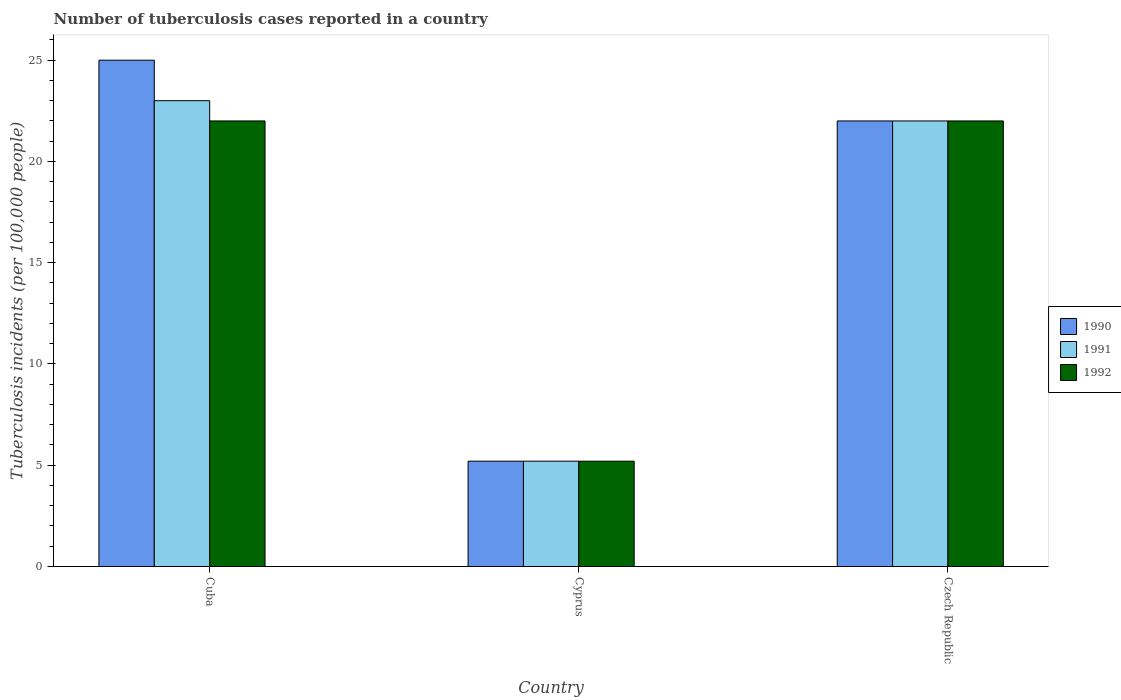How many groups of bars are there?
Ensure brevity in your answer.  3. Are the number of bars per tick equal to the number of legend labels?
Your response must be concise. Yes. Are the number of bars on each tick of the X-axis equal?
Provide a short and direct response. Yes. What is the label of the 1st group of bars from the left?
Your answer should be very brief. Cuba. Across all countries, what is the minimum number of tuberculosis cases reported in in 1991?
Your answer should be very brief. 5.2. In which country was the number of tuberculosis cases reported in in 1991 maximum?
Offer a very short reply. Cuba. In which country was the number of tuberculosis cases reported in in 1991 minimum?
Your answer should be very brief. Cyprus. What is the total number of tuberculosis cases reported in in 1991 in the graph?
Ensure brevity in your answer.  50.2. What is the difference between the number of tuberculosis cases reported in in 1992 in Cyprus and that in Czech Republic?
Make the answer very short. -16.8. What is the difference between the number of tuberculosis cases reported in in 1991 in Cyprus and the number of tuberculosis cases reported in in 1992 in Czech Republic?
Ensure brevity in your answer.  -16.8. What is the average number of tuberculosis cases reported in in 1992 per country?
Make the answer very short. 16.4. In how many countries, is the number of tuberculosis cases reported in in 1990 greater than 12?
Ensure brevity in your answer.  2. What is the ratio of the number of tuberculosis cases reported in in 1992 in Cuba to that in Czech Republic?
Your answer should be very brief. 1. Is the difference between the number of tuberculosis cases reported in in 1991 in Cuba and Cyprus greater than the difference between the number of tuberculosis cases reported in in 1990 in Cuba and Cyprus?
Provide a short and direct response. No. What is the difference between the highest and the second highest number of tuberculosis cases reported in in 1992?
Make the answer very short. -16.8. What is the difference between the highest and the lowest number of tuberculosis cases reported in in 1991?
Make the answer very short. 17.8. Is the sum of the number of tuberculosis cases reported in in 1991 in Cyprus and Czech Republic greater than the maximum number of tuberculosis cases reported in in 1990 across all countries?
Give a very brief answer. Yes. What does the 2nd bar from the left in Czech Republic represents?
Your answer should be compact. 1991. What does the 3rd bar from the right in Cyprus represents?
Provide a short and direct response. 1990. Are all the bars in the graph horizontal?
Give a very brief answer. No. How many countries are there in the graph?
Give a very brief answer. 3. What is the difference between two consecutive major ticks on the Y-axis?
Offer a very short reply. 5. Are the values on the major ticks of Y-axis written in scientific E-notation?
Provide a succinct answer. No. Where does the legend appear in the graph?
Make the answer very short. Center right. How are the legend labels stacked?
Make the answer very short. Vertical. What is the title of the graph?
Provide a short and direct response. Number of tuberculosis cases reported in a country. Does "2015" appear as one of the legend labels in the graph?
Keep it short and to the point. No. What is the label or title of the Y-axis?
Provide a succinct answer. Tuberculosis incidents (per 100,0 people). What is the Tuberculosis incidents (per 100,000 people) in 1991 in Cuba?
Provide a succinct answer. 23. What is the Tuberculosis incidents (per 100,000 people) in 1992 in Cuba?
Provide a succinct answer. 22. What is the Tuberculosis incidents (per 100,000 people) of 1990 in Cyprus?
Ensure brevity in your answer.  5.2. What is the Tuberculosis incidents (per 100,000 people) of 1992 in Cyprus?
Offer a very short reply. 5.2. What is the Tuberculosis incidents (per 100,000 people) in 1990 in Czech Republic?
Your answer should be compact. 22. What is the Tuberculosis incidents (per 100,000 people) of 1991 in Czech Republic?
Your answer should be compact. 22. Across all countries, what is the maximum Tuberculosis incidents (per 100,000 people) of 1991?
Keep it short and to the point. 23. Across all countries, what is the minimum Tuberculosis incidents (per 100,000 people) in 1990?
Your answer should be very brief. 5.2. What is the total Tuberculosis incidents (per 100,000 people) in 1990 in the graph?
Offer a very short reply. 52.2. What is the total Tuberculosis incidents (per 100,000 people) of 1991 in the graph?
Offer a terse response. 50.2. What is the total Tuberculosis incidents (per 100,000 people) of 1992 in the graph?
Make the answer very short. 49.2. What is the difference between the Tuberculosis incidents (per 100,000 people) in 1990 in Cuba and that in Cyprus?
Offer a very short reply. 19.8. What is the difference between the Tuberculosis incidents (per 100,000 people) in 1991 in Cuba and that in Cyprus?
Your answer should be compact. 17.8. What is the difference between the Tuberculosis incidents (per 100,000 people) in 1992 in Cuba and that in Cyprus?
Your answer should be compact. 16.8. What is the difference between the Tuberculosis incidents (per 100,000 people) in 1990 in Cyprus and that in Czech Republic?
Keep it short and to the point. -16.8. What is the difference between the Tuberculosis incidents (per 100,000 people) in 1991 in Cyprus and that in Czech Republic?
Give a very brief answer. -16.8. What is the difference between the Tuberculosis incidents (per 100,000 people) of 1992 in Cyprus and that in Czech Republic?
Your answer should be very brief. -16.8. What is the difference between the Tuberculosis incidents (per 100,000 people) in 1990 in Cuba and the Tuberculosis incidents (per 100,000 people) in 1991 in Cyprus?
Ensure brevity in your answer.  19.8. What is the difference between the Tuberculosis incidents (per 100,000 people) in 1990 in Cuba and the Tuberculosis incidents (per 100,000 people) in 1992 in Cyprus?
Your answer should be very brief. 19.8. What is the difference between the Tuberculosis incidents (per 100,000 people) in 1991 in Cuba and the Tuberculosis incidents (per 100,000 people) in 1992 in Cyprus?
Provide a succinct answer. 17.8. What is the difference between the Tuberculosis incidents (per 100,000 people) of 1990 in Cuba and the Tuberculosis incidents (per 100,000 people) of 1991 in Czech Republic?
Ensure brevity in your answer.  3. What is the difference between the Tuberculosis incidents (per 100,000 people) in 1991 in Cuba and the Tuberculosis incidents (per 100,000 people) in 1992 in Czech Republic?
Your answer should be compact. 1. What is the difference between the Tuberculosis incidents (per 100,000 people) of 1990 in Cyprus and the Tuberculosis incidents (per 100,000 people) of 1991 in Czech Republic?
Provide a short and direct response. -16.8. What is the difference between the Tuberculosis incidents (per 100,000 people) of 1990 in Cyprus and the Tuberculosis incidents (per 100,000 people) of 1992 in Czech Republic?
Make the answer very short. -16.8. What is the difference between the Tuberculosis incidents (per 100,000 people) of 1991 in Cyprus and the Tuberculosis incidents (per 100,000 people) of 1992 in Czech Republic?
Your answer should be compact. -16.8. What is the average Tuberculosis incidents (per 100,000 people) of 1991 per country?
Your response must be concise. 16.73. What is the average Tuberculosis incidents (per 100,000 people) of 1992 per country?
Your answer should be very brief. 16.4. What is the difference between the Tuberculosis incidents (per 100,000 people) of 1990 and Tuberculosis incidents (per 100,000 people) of 1991 in Cuba?
Keep it short and to the point. 2. What is the difference between the Tuberculosis incidents (per 100,000 people) in 1991 and Tuberculosis incidents (per 100,000 people) in 1992 in Cuba?
Keep it short and to the point. 1. What is the ratio of the Tuberculosis incidents (per 100,000 people) of 1990 in Cuba to that in Cyprus?
Your response must be concise. 4.81. What is the ratio of the Tuberculosis incidents (per 100,000 people) of 1991 in Cuba to that in Cyprus?
Ensure brevity in your answer.  4.42. What is the ratio of the Tuberculosis incidents (per 100,000 people) in 1992 in Cuba to that in Cyprus?
Provide a short and direct response. 4.23. What is the ratio of the Tuberculosis incidents (per 100,000 people) of 1990 in Cuba to that in Czech Republic?
Offer a very short reply. 1.14. What is the ratio of the Tuberculosis incidents (per 100,000 people) of 1991 in Cuba to that in Czech Republic?
Offer a terse response. 1.05. What is the ratio of the Tuberculosis incidents (per 100,000 people) in 1992 in Cuba to that in Czech Republic?
Your answer should be very brief. 1. What is the ratio of the Tuberculosis incidents (per 100,000 people) in 1990 in Cyprus to that in Czech Republic?
Give a very brief answer. 0.24. What is the ratio of the Tuberculosis incidents (per 100,000 people) of 1991 in Cyprus to that in Czech Republic?
Provide a succinct answer. 0.24. What is the ratio of the Tuberculosis incidents (per 100,000 people) in 1992 in Cyprus to that in Czech Republic?
Provide a succinct answer. 0.24. What is the difference between the highest and the second highest Tuberculosis incidents (per 100,000 people) in 1990?
Your answer should be very brief. 3. What is the difference between the highest and the second highest Tuberculosis incidents (per 100,000 people) in 1991?
Offer a terse response. 1. What is the difference between the highest and the second highest Tuberculosis incidents (per 100,000 people) in 1992?
Offer a terse response. 0. What is the difference between the highest and the lowest Tuberculosis incidents (per 100,000 people) in 1990?
Provide a succinct answer. 19.8. What is the difference between the highest and the lowest Tuberculosis incidents (per 100,000 people) of 1991?
Make the answer very short. 17.8. What is the difference between the highest and the lowest Tuberculosis incidents (per 100,000 people) in 1992?
Your answer should be compact. 16.8. 